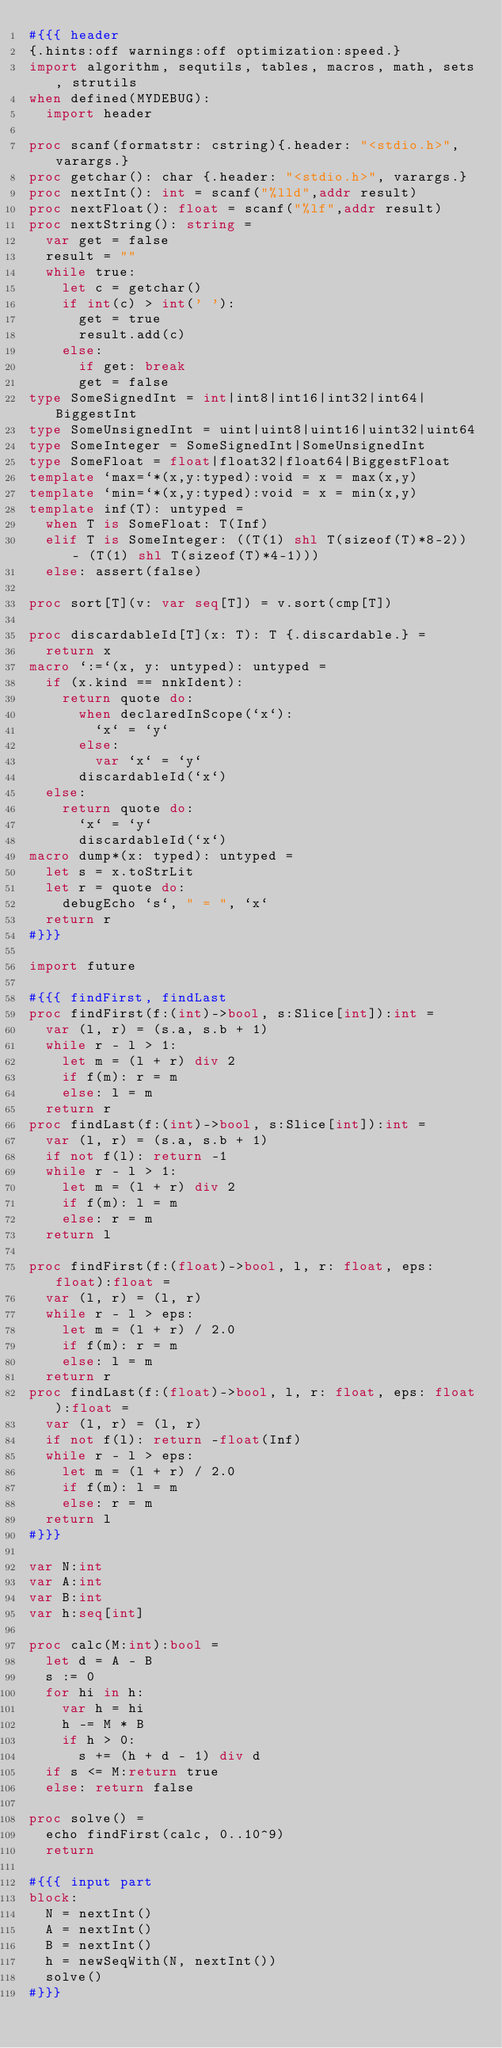Convert code to text. <code><loc_0><loc_0><loc_500><loc_500><_Nim_>#{{{ header
{.hints:off warnings:off optimization:speed.}
import algorithm, sequtils, tables, macros, math, sets, strutils
when defined(MYDEBUG):
  import header

proc scanf(formatstr: cstring){.header: "<stdio.h>", varargs.}
proc getchar(): char {.header: "<stdio.h>", varargs.}
proc nextInt(): int = scanf("%lld",addr result)
proc nextFloat(): float = scanf("%lf",addr result)
proc nextString(): string =
  var get = false
  result = ""
  while true:
    let c = getchar()
    if int(c) > int(' '):
      get = true
      result.add(c)
    else:
      if get: break
      get = false
type SomeSignedInt = int|int8|int16|int32|int64|BiggestInt
type SomeUnsignedInt = uint|uint8|uint16|uint32|uint64
type SomeInteger = SomeSignedInt|SomeUnsignedInt
type SomeFloat = float|float32|float64|BiggestFloat
template `max=`*(x,y:typed):void = x = max(x,y)
template `min=`*(x,y:typed):void = x = min(x,y)
template inf(T): untyped = 
  when T is SomeFloat: T(Inf)
  elif T is SomeInteger: ((T(1) shl T(sizeof(T)*8-2)) - (T(1) shl T(sizeof(T)*4-1)))
  else: assert(false)

proc sort[T](v: var seq[T]) = v.sort(cmp[T])

proc discardableId[T](x: T): T {.discardable.} =
  return x
macro `:=`(x, y: untyped): untyped =
  if (x.kind == nnkIdent):
    return quote do:
      when declaredInScope(`x`):
        `x` = `y`
      else:
        var `x` = `y`
      discardableId(`x`)
  else:
    return quote do:
      `x` = `y`
      discardableId(`x`)
macro dump*(x: typed): untyped =
  let s = x.toStrLit
  let r = quote do:
    debugEcho `s`, " = ", `x`
  return r
#}}}

import future

#{{{ findFirst, findLast
proc findFirst(f:(int)->bool, s:Slice[int]):int =
  var (l, r) = (s.a, s.b + 1)
  while r - l > 1:
    let m = (l + r) div 2
    if f(m): r = m
    else: l = m
  return r
proc findLast(f:(int)->bool, s:Slice[int]):int =
  var (l, r) = (s.a, s.b + 1)
  if not f(l): return -1
  while r - l > 1:
    let m = (l + r) div 2
    if f(m): l = m
    else: r = m
  return l

proc findFirst(f:(float)->bool, l, r: float, eps: float):float =
  var (l, r) = (l, r)
  while r - l > eps:
    let m = (l + r) / 2.0
    if f(m): r = m
    else: l = m
  return r
proc findLast(f:(float)->bool, l, r: float, eps: float):float =
  var (l, r) = (l, r)
  if not f(l): return -float(Inf)
  while r - l > eps:
    let m = (l + r) / 2.0
    if f(m): l = m
    else: r = m
  return l
#}}}

var N:int
var A:int
var B:int
var h:seq[int]

proc calc(M:int):bool =
  let d = A - B
  s := 0
  for hi in h:
    var h = hi
    h -= M * B
    if h > 0:
      s += (h + d - 1) div d
  if s <= M:return true
  else: return false

proc solve() =
  echo findFirst(calc, 0..10^9)
  return

#{{{ input part
block:
  N = nextInt()
  A = nextInt()
  B = nextInt()
  h = newSeqWith(N, nextInt())
  solve()
#}}}</code> 